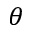<formula> <loc_0><loc_0><loc_500><loc_500>\theta</formula> 